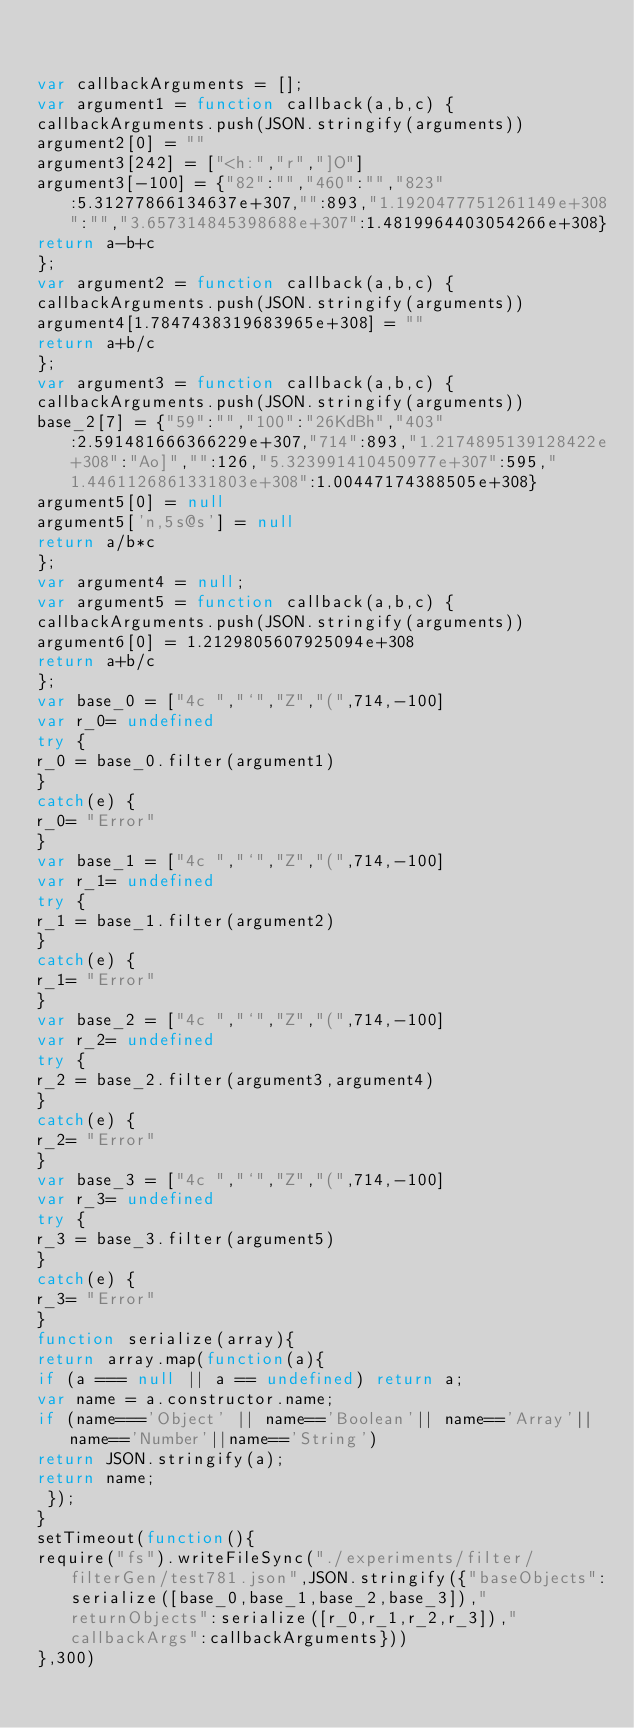<code> <loc_0><loc_0><loc_500><loc_500><_JavaScript_>

var callbackArguments = [];
var argument1 = function callback(a,b,c) { 
callbackArguments.push(JSON.stringify(arguments))
argument2[0] = ""
argument3[242] = ["<h:","r","]O"]
argument3[-100] = {"82":"","460":"","823":5.31277866134637e+307,"":893,"1.1920477751261149e+308":"","3.657314845398688e+307":1.4819964403054266e+308}
return a-b+c
};
var argument2 = function callback(a,b,c) { 
callbackArguments.push(JSON.stringify(arguments))
argument4[1.7847438319683965e+308] = ""
return a+b/c
};
var argument3 = function callback(a,b,c) { 
callbackArguments.push(JSON.stringify(arguments))
base_2[7] = {"59":"","100":"26KdBh","403":2.591481666366229e+307,"714":893,"1.2174895139128422e+308":"Ao]","":126,"5.323991410450977e+307":595,"1.4461126861331803e+308":1.00447174388505e+308}
argument5[0] = null
argument5['n,5s@s'] = null
return a/b*c
};
var argument4 = null;
var argument5 = function callback(a,b,c) { 
callbackArguments.push(JSON.stringify(arguments))
argument6[0] = 1.2129805607925094e+308
return a+b/c
};
var base_0 = ["4c ","`","Z","(",714,-100]
var r_0= undefined
try {
r_0 = base_0.filter(argument1)
}
catch(e) {
r_0= "Error"
}
var base_1 = ["4c ","`","Z","(",714,-100]
var r_1= undefined
try {
r_1 = base_1.filter(argument2)
}
catch(e) {
r_1= "Error"
}
var base_2 = ["4c ","`","Z","(",714,-100]
var r_2= undefined
try {
r_2 = base_2.filter(argument3,argument4)
}
catch(e) {
r_2= "Error"
}
var base_3 = ["4c ","`","Z","(",714,-100]
var r_3= undefined
try {
r_3 = base_3.filter(argument5)
}
catch(e) {
r_3= "Error"
}
function serialize(array){
return array.map(function(a){
if (a === null || a == undefined) return a;
var name = a.constructor.name;
if (name==='Object' || name=='Boolean'|| name=='Array'||name=='Number'||name=='String')
return JSON.stringify(a);
return name;
 });
}
setTimeout(function(){
require("fs").writeFileSync("./experiments/filter/filterGen/test781.json",JSON.stringify({"baseObjects":serialize([base_0,base_1,base_2,base_3]),"returnObjects":serialize([r_0,r_1,r_2,r_3]),"callbackArgs":callbackArguments}))
},300)</code> 